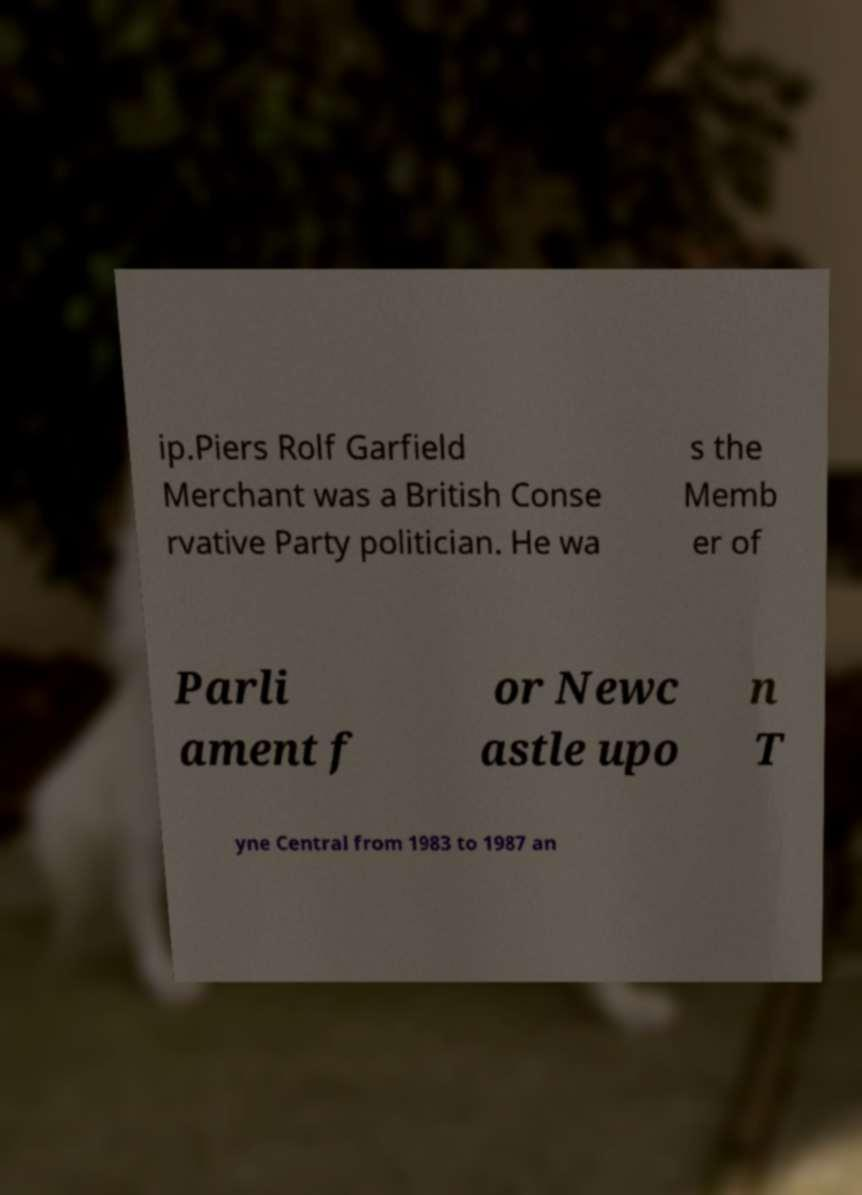Can you accurately transcribe the text from the provided image for me? ip.Piers Rolf Garfield Merchant was a British Conse rvative Party politician. He wa s the Memb er of Parli ament f or Newc astle upo n T yne Central from 1983 to 1987 an 